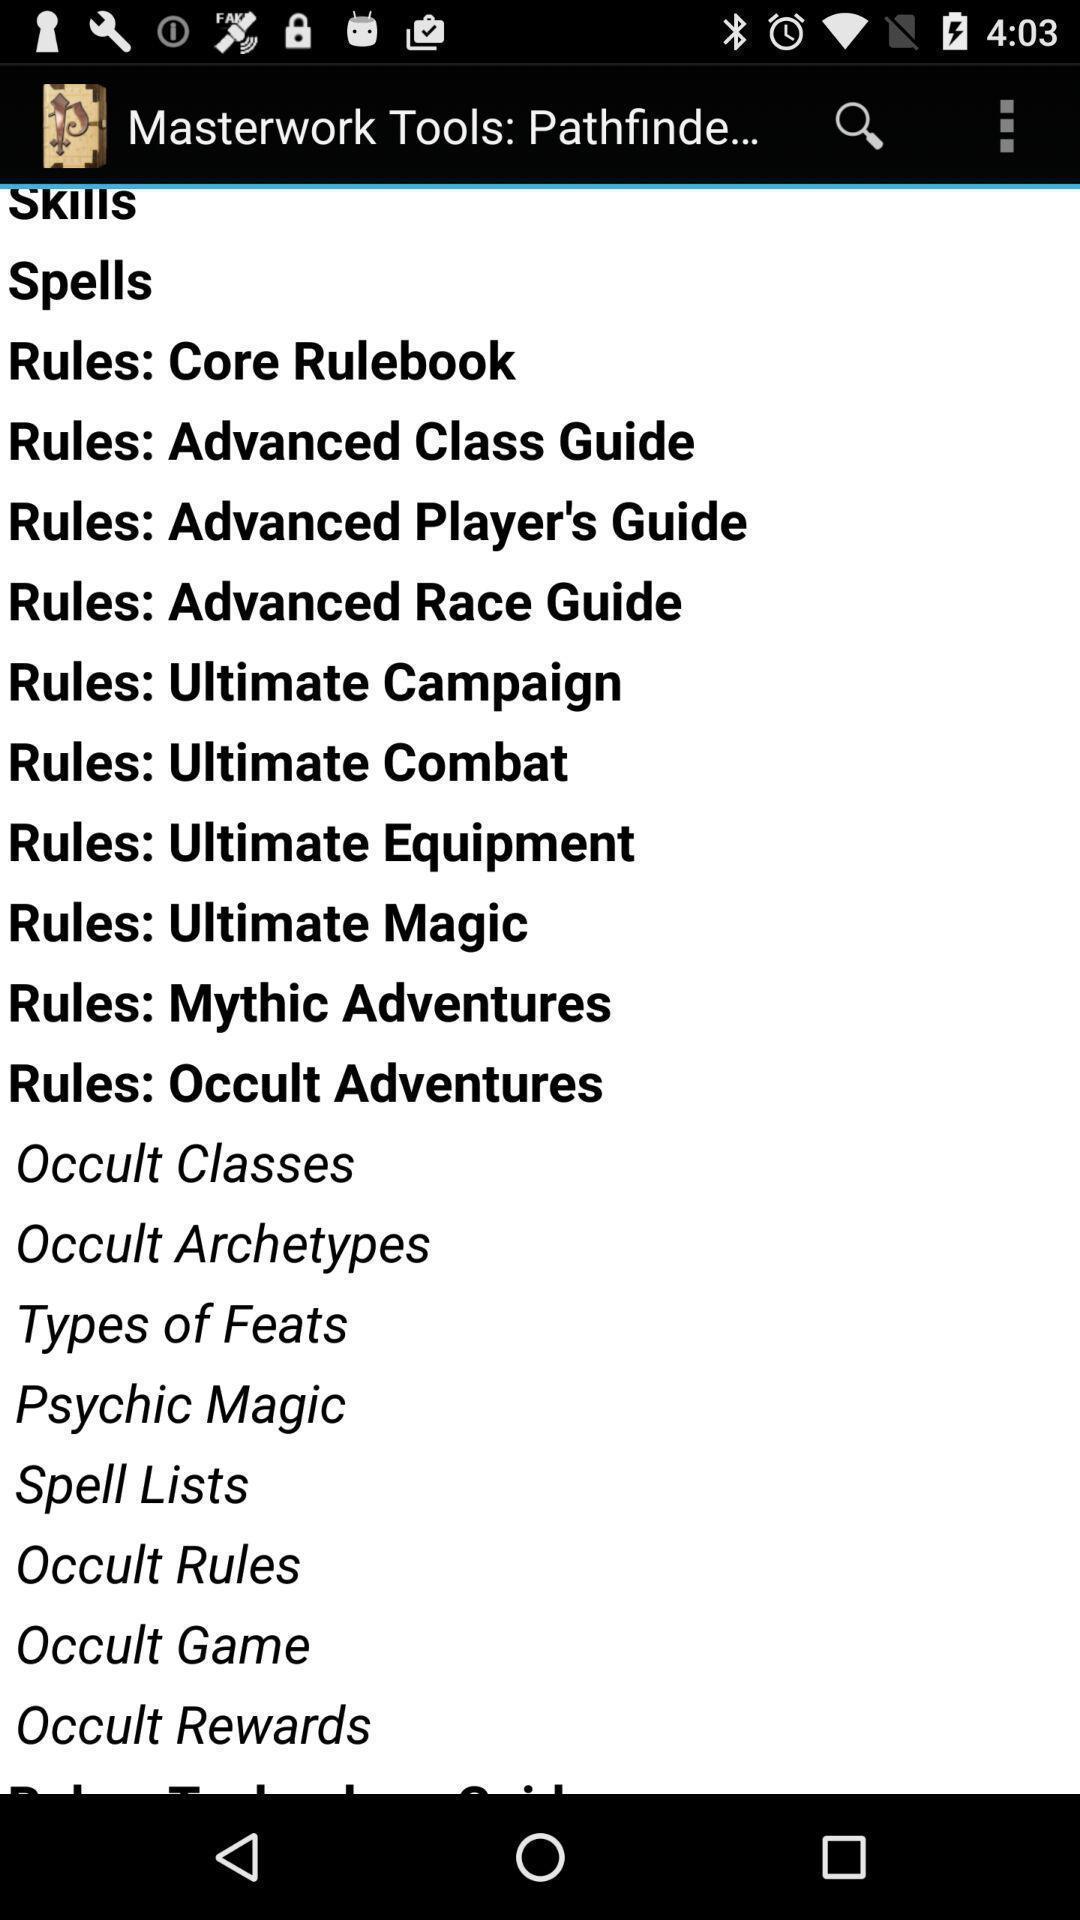Describe the visual elements of this screenshot. Screen displaying spells. 